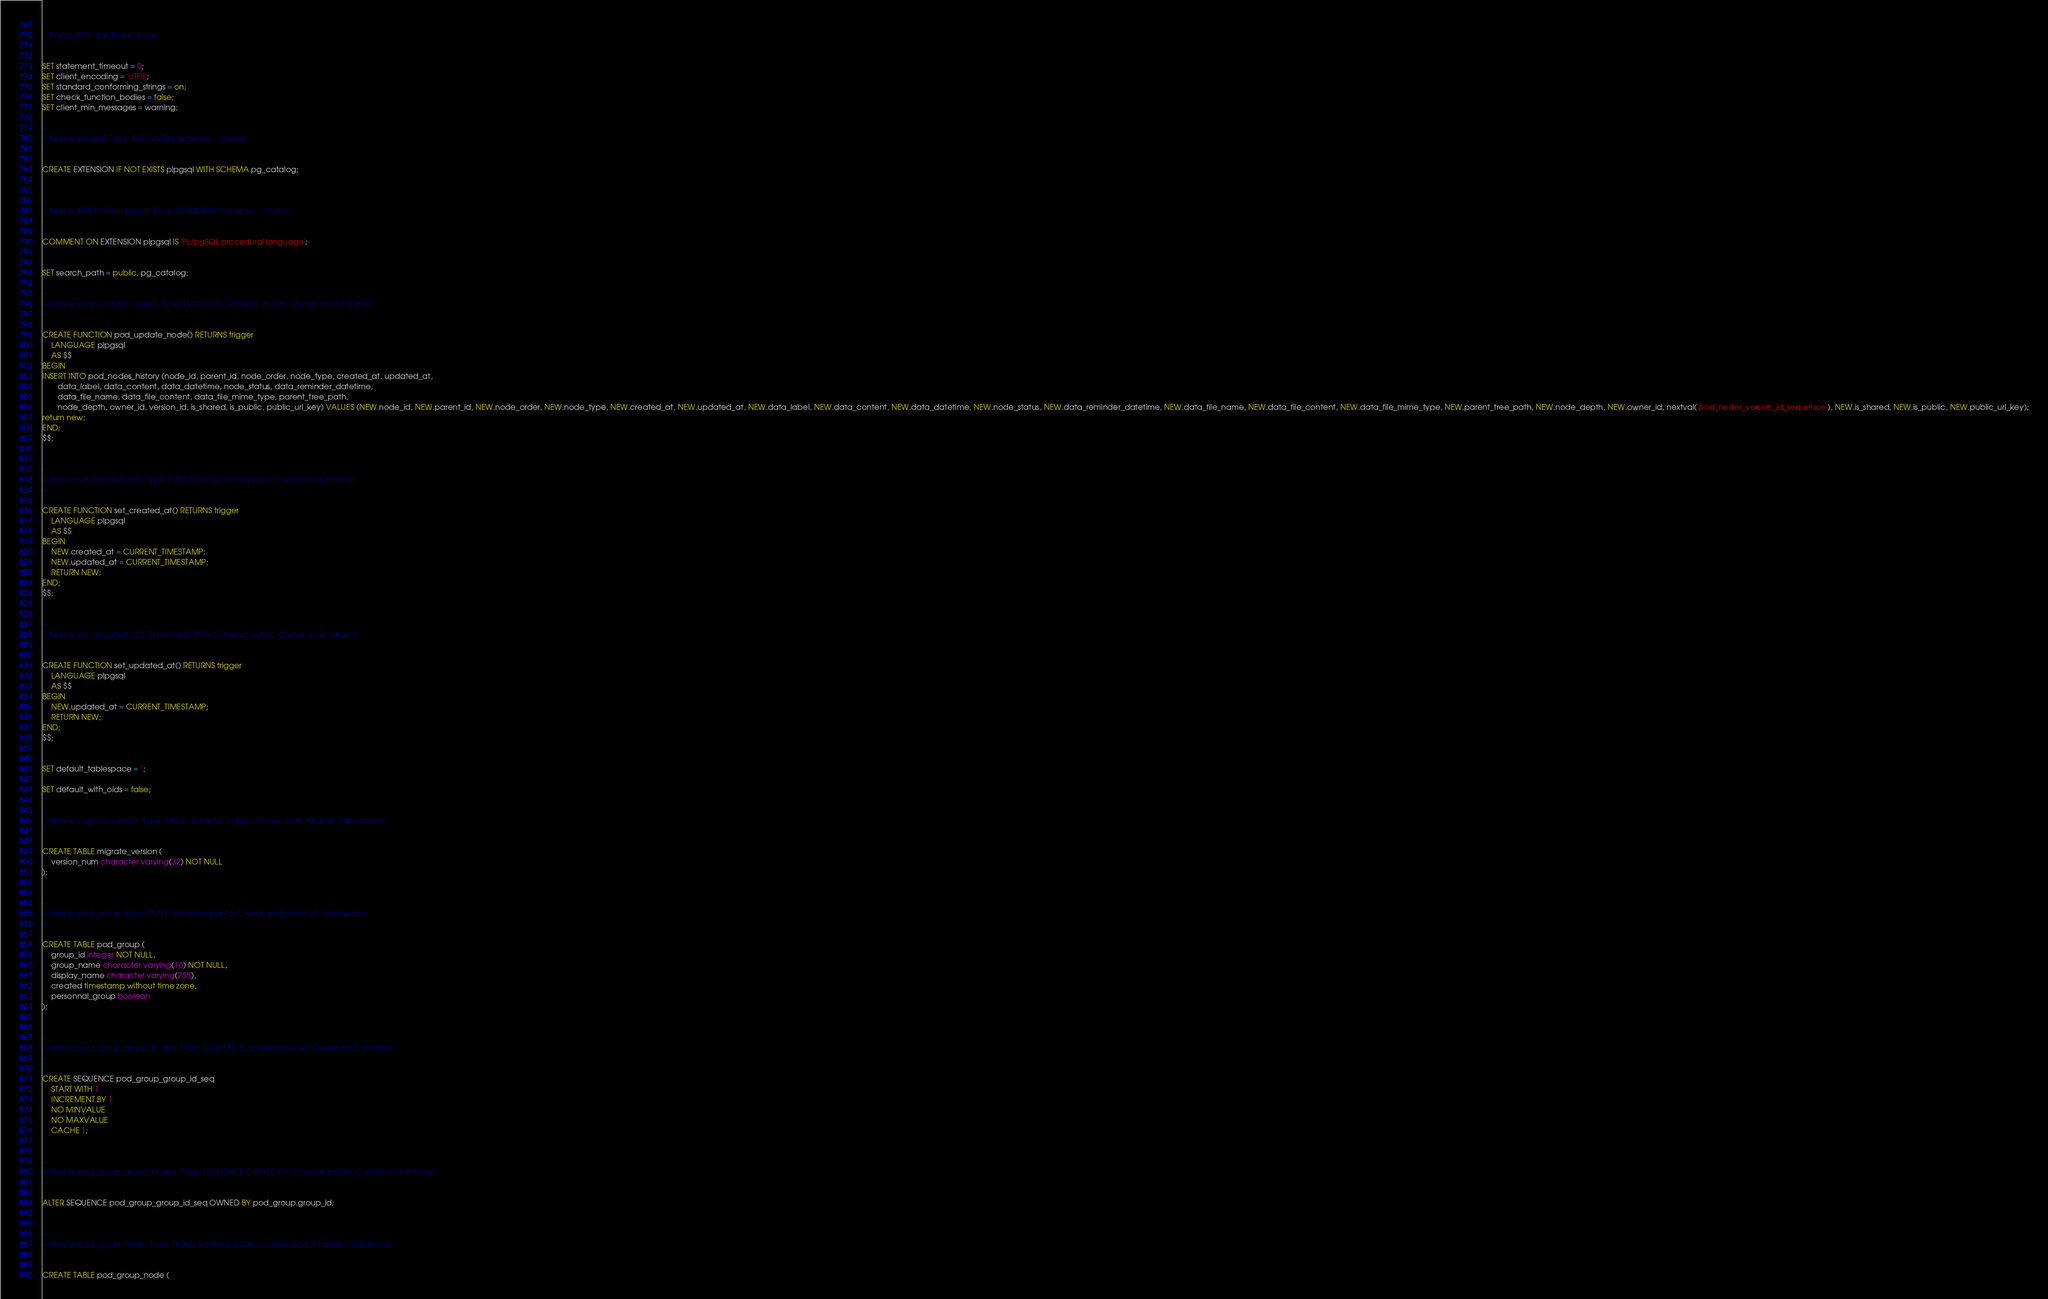Convert code to text. <code><loc_0><loc_0><loc_500><loc_500><_SQL_>--
-- PostgreSQL database dump
--

SET statement_timeout = 0;
SET client_encoding = 'UTF8';
SET standard_conforming_strings = on;
SET check_function_bodies = false;
SET client_min_messages = warning;

--
-- Name: plpgsql; Type: EXTENSION; Schema: -; Owner: 
--

CREATE EXTENSION IF NOT EXISTS plpgsql WITH SCHEMA pg_catalog;


--
-- Name: EXTENSION plpgsql; Type: COMMENT; Schema: -; Owner: 
--

COMMENT ON EXTENSION plpgsql IS 'PL/pgSQL procedural language';


SET search_path = public, pg_catalog;

--
-- Name: pod_update_node(); Type: FUNCTION; Schema: public; Owner: pod_intranet
--

CREATE FUNCTION pod_update_node() RETURNS trigger
    LANGUAGE plpgsql
    AS $$
BEGIN
INSERT INTO pod_nodes_history (node_id, parent_id, node_order, node_type, created_at, updated_at, 
       data_label, data_content, data_datetime, node_status, data_reminder_datetime, 
       data_file_name, data_file_content, data_file_mime_type, parent_tree_path, 
       node_depth, owner_id, version_id, is_shared, is_public, public_url_key) VALUES (NEW.node_id, NEW.parent_id, NEW.node_order, NEW.node_type, NEW.created_at, NEW.updated_at, NEW.data_label, NEW.data_content, NEW.data_datetime, NEW.node_status, NEW.data_reminder_datetime, NEW.data_file_name, NEW.data_file_content, NEW.data_file_mime_type, NEW.parent_tree_path, NEW.node_depth, NEW.owner_id, nextval('pod_nodes_version_id_sequence'), NEW.is_shared, NEW.is_public, NEW.public_url_key);
return new;
END;
$$;


--
-- Name: set_created_at(); Type: FUNCTION; Schema: public; Owner: pod_intranet
--

CREATE FUNCTION set_created_at() RETURNS trigger
    LANGUAGE plpgsql
    AS $$
BEGIN
    NEW.created_at = CURRENT_TIMESTAMP;
    NEW.updated_at = CURRENT_TIMESTAMP;
    RETURN NEW;
END;
$$;


--
-- Name: set_updated_at(); Type: FUNCTION; Schema: public; Owner: pod_intranet
--

CREATE FUNCTION set_updated_at() RETURNS trigger
    LANGUAGE plpgsql
    AS $$
BEGIN
    NEW.updated_at = CURRENT_TIMESTAMP;
    RETURN NEW;
END;
$$;


SET default_tablespace = '';

SET default_with_oids = false;

--
-- Name: migrate_version; Type: TABLE; Schema: public; Owner: pod_intranet; Tablespace: 
--

CREATE TABLE migrate_version (
    version_num character varying(32) NOT NULL
);


--
-- Name: pod_group; Type: TABLE; Schema: public; Owner: pod_intranet; Tablespace: 
--

CREATE TABLE pod_group (
    group_id integer NOT NULL,
    group_name character varying(16) NOT NULL,
    display_name character varying(255),
    created timestamp without time zone,
    personnal_group boolean
);


--
-- Name: pod_group_group_id_seq; Type: SEQUENCE; Schema: public; Owner: pod_intranet
--

CREATE SEQUENCE pod_group_group_id_seq
    START WITH 1
    INCREMENT BY 1
    NO MINVALUE
    NO MAXVALUE
    CACHE 1;


--
-- Name: pod_group_group_id_seq; Type: SEQUENCE OWNED BY; Schema: public; Owner: pod_intranet
--

ALTER SEQUENCE pod_group_group_id_seq OWNED BY pod_group.group_id;


--
-- Name: pod_group_node; Type: TABLE; Schema: public; Owner: pod_intranet; Tablespace: 
--

CREATE TABLE pod_group_node (</code> 